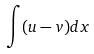Convert formula to latex. <formula><loc_0><loc_0><loc_500><loc_500>\int ( u - v ) d x</formula> 